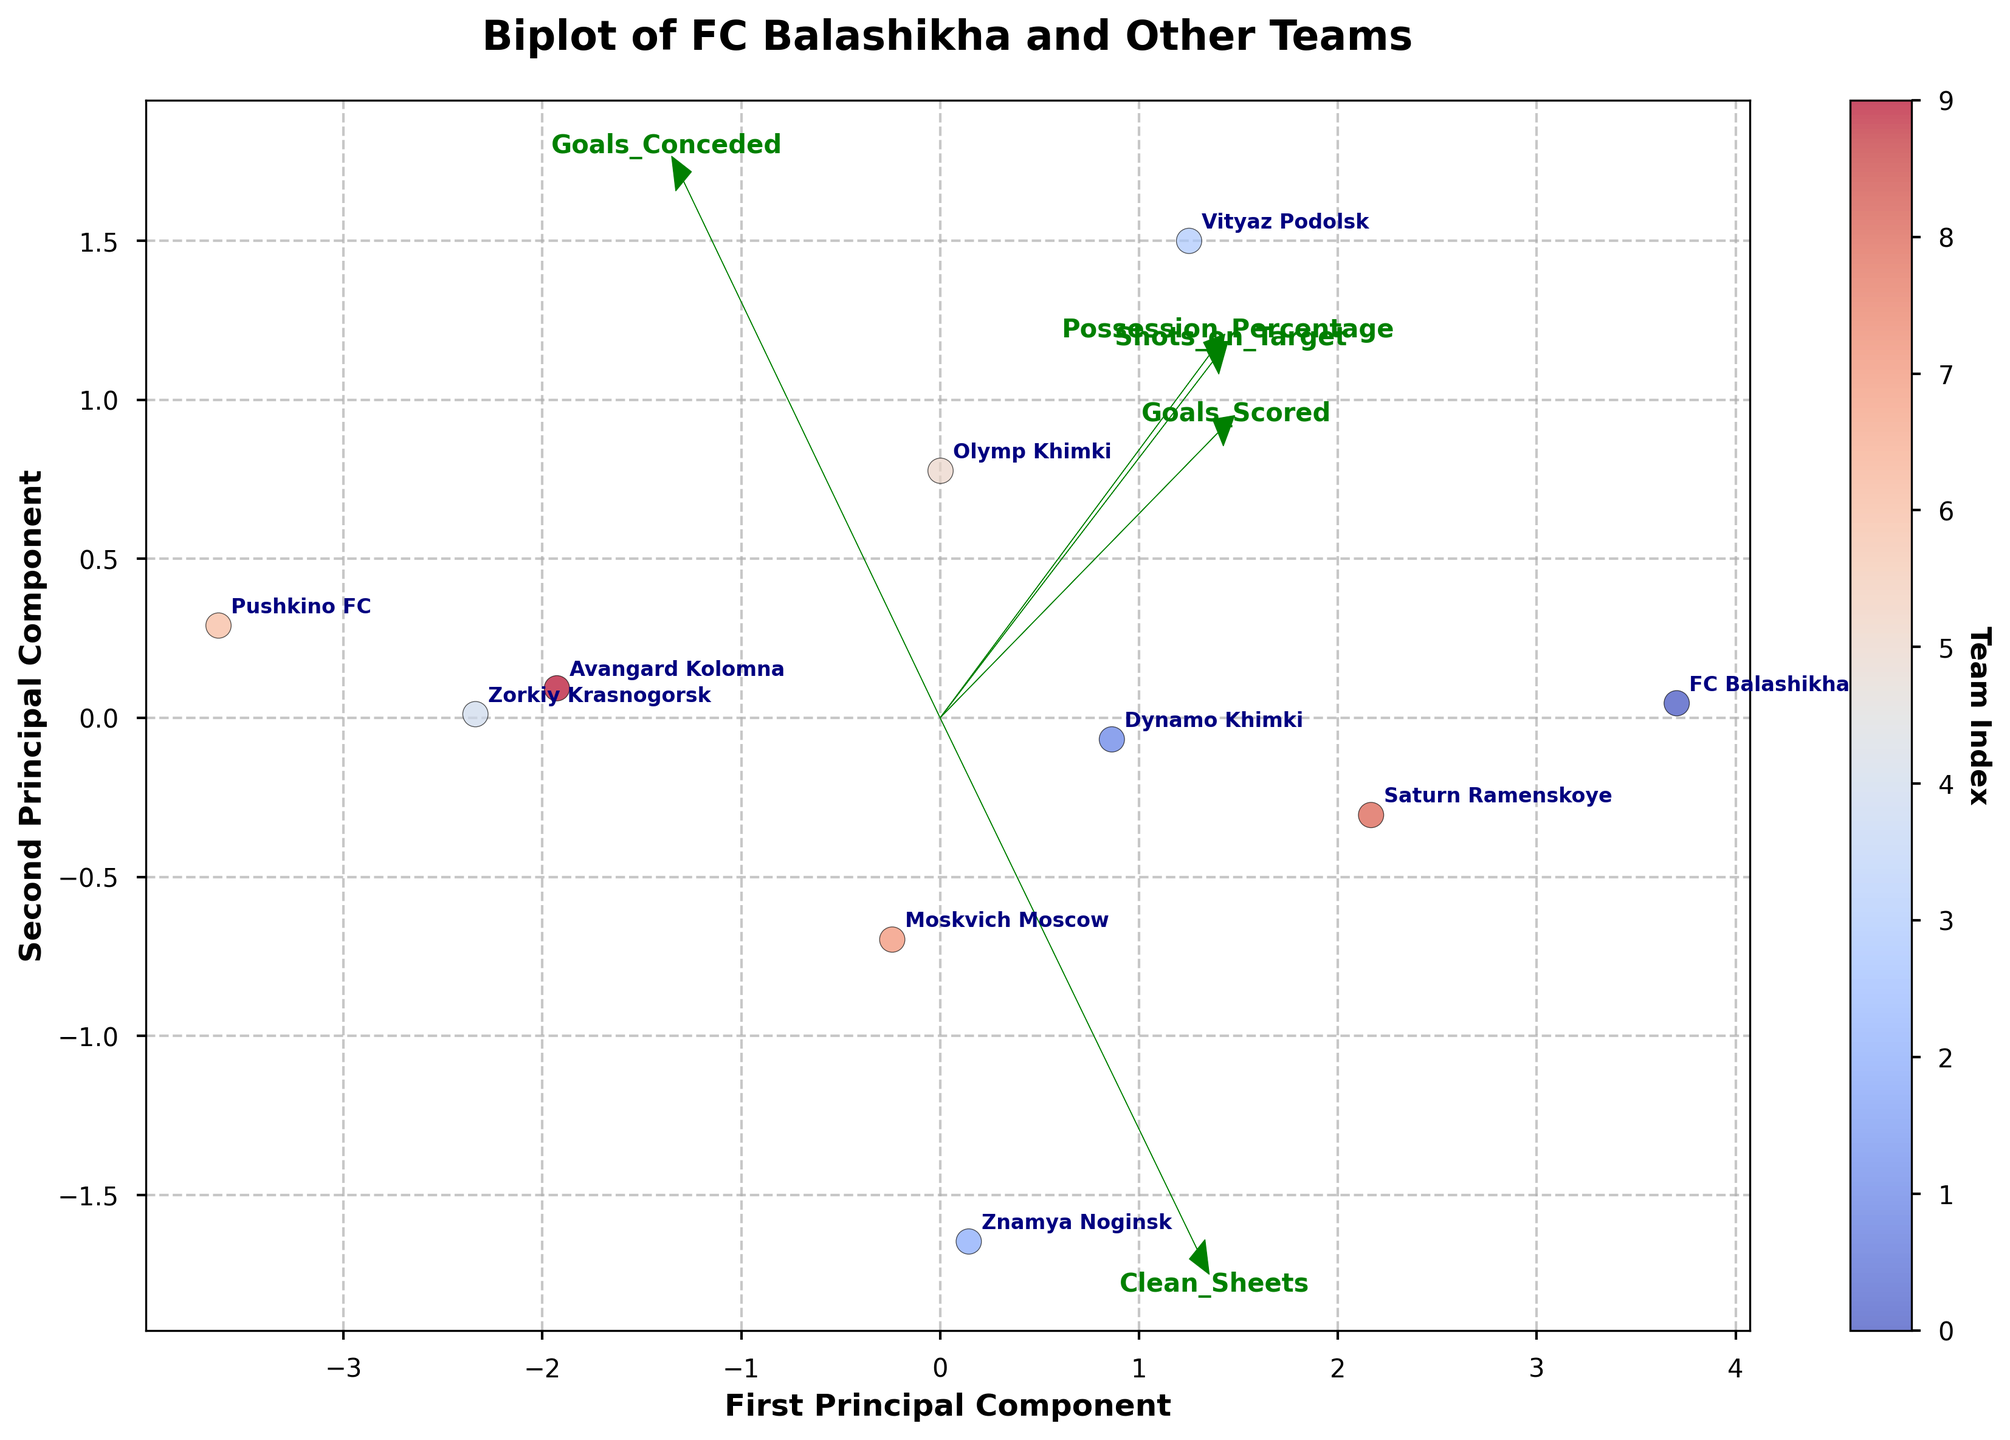Where is FC Balashikha positioned on the plot? FC Balashikha is labeled on the plot. By locating the label 'FC Balashikha,' we can find its position among the data points.
Answer: Found near the center, slightly towards the upper right Which team has the highest first principal component score? By examining the x-axis (First Principal Component), we look for the data point that is furthest to the right, then identify the corresponding team label.
Answer: Vityaz Podolsk Which team has the lowest second principal component score? By examining the y-axis (Second Principal Component), we look for the data point that is furthest downwards, then identify the corresponding team label.
Answer: Pushkino FC What feature most aligns with the first principal component? By observing the direction of the feature vectors, we identify which vector aligns most closely with the x-axis (First Principal Component).
Answer: Goals Scored How are teams with higher possession percentages positioned on the plot? By looking at the direction of the Possession_Percentage vector, we can see in which direction teams with higher possession percentages (aligned with this vector) are situated.
Answer: Upper and to the right Is there any team closer to the origin of the plot? By locating the origin and identifying the closest data point, we can determine the team nearest to it.
Answer: Moskvich Moscow Which feature appears to be least correlated with the second principal component? We analyze the feature vectors and observe which one is least aligned with the y-axis (Second Principal Component).
Answer: Shots on Target Which two teams are positioned closest to each other on the biplot? By observing the distances between the data points, we find the two teams whose data points are nearest to one another.
Answer: Dynamo Khimki and Olymp Khimki Do FC Balashikha and Znamya Noginsk show similar performance characteristics? By comparing the positions of FC Balashikha and Znamya Noginsk on the plot, we can see if they are close, indicating similar performance characteristics.
Answer: No, they are not close Which feature vector points most towards the upper left quadrant? By looking at the directions of the feature vectors, we identify which one points towards the upper left quadrant of the plot.
Answer: Clean Sheets 